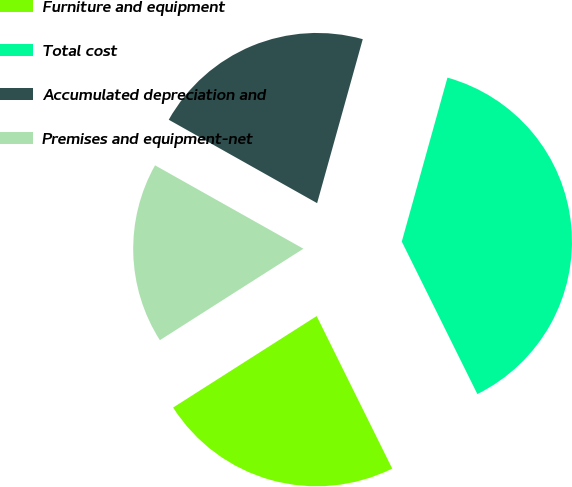Convert chart. <chart><loc_0><loc_0><loc_500><loc_500><pie_chart><fcel>Furniture and equipment<fcel>Total cost<fcel>Accumulated depreciation and<fcel>Premises and equipment-net<nl><fcel>23.29%<fcel>38.35%<fcel>21.17%<fcel>17.18%<nl></chart> 